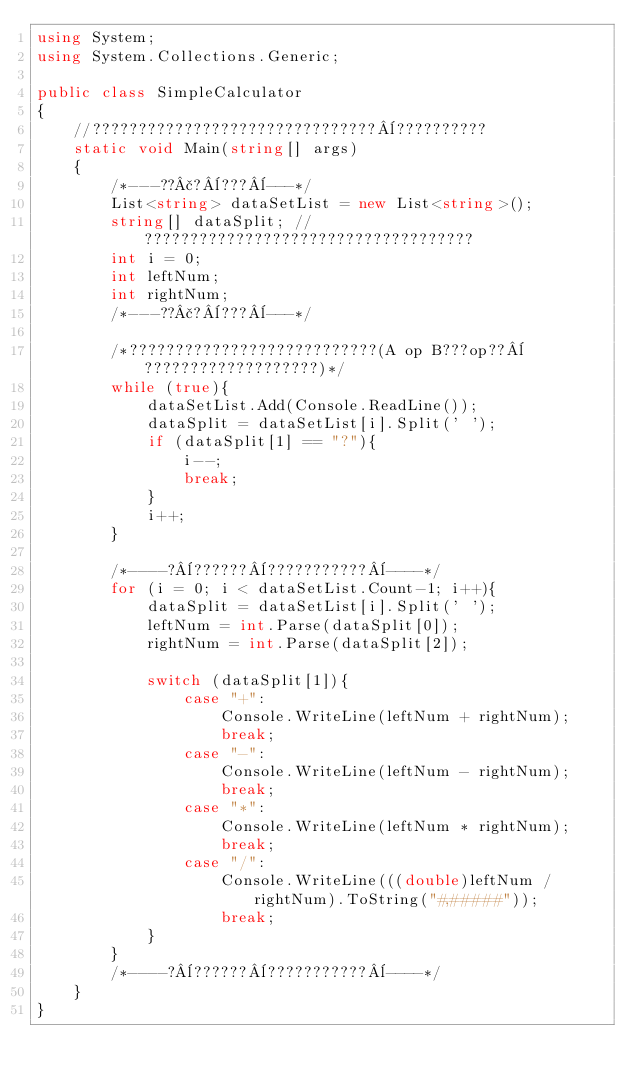Convert code to text. <code><loc_0><loc_0><loc_500><loc_500><_C#_>using System;
using System.Collections.Generic;

public class SimpleCalculator
{
    //???????????????????????????????¨??????????
    static void Main(string[] args)
    {
        /*---??£?¨???¨---*/
        List<string> dataSetList = new List<string>();
        string[] dataSplit; //????????????????????????????????????
        int i = 0;
        int leftNum;
        int rightNum;
        /*---??£?¨???¨---*/

        /*???????????????????????????(A op B???op??¨???????????????????)*/
        while (true){
            dataSetList.Add(Console.ReadLine());
            dataSplit = dataSetList[i].Split(' ');
            if (dataSplit[1] == "?"){
                i--;
                break;
            }
            i++;
        }

        /*----?¨??????¨???????????¨----*/
        for (i = 0; i < dataSetList.Count-1; i++){
            dataSplit = dataSetList[i].Split(' ');
            leftNum = int.Parse(dataSplit[0]);
            rightNum = int.Parse(dataSplit[2]);

            switch (dataSplit[1]){
                case "+":
                    Console.WriteLine(leftNum + rightNum);
                    break;
                case "-":
                    Console.WriteLine(leftNum - rightNum);
                    break;
                case "*":
                    Console.WriteLine(leftNum * rightNum);
                    break;
                case "/":
                    Console.WriteLine(((double)leftNum / rightNum).ToString("#,#####"));
                    break;
            }
        }
        /*----?¨??????¨???????????¨----*/
    }
}</code> 